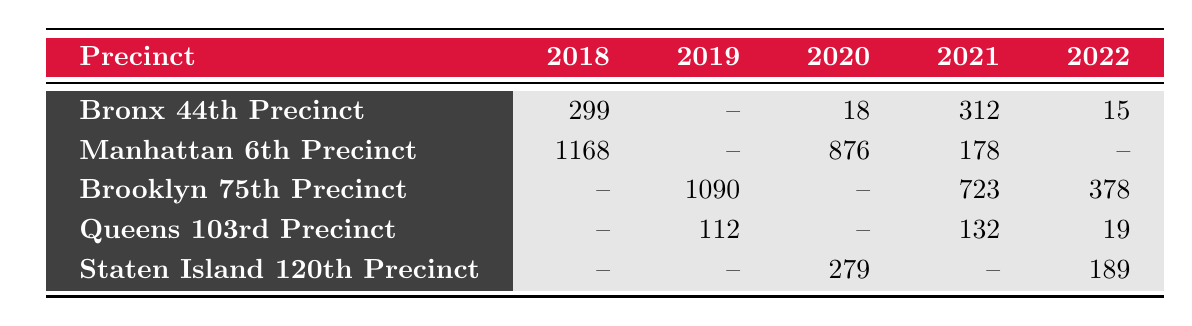What is the total number of offenses recorded in the Bronx 44th Precinct from 2018 to 2022? Looking at the Bronx 44th Precinct row, we see values for 2018 (299), 2020 (18), 2021 (312), and 2022 (15). We add these numbers: 299 + 18 + 312 + 15 = 644. There are no data points for 2019.
Answer: 644 Which year had the highest count of Grand Larceny in Manhattan 6th Precinct? The only year with data for Grand Larceny in the Manhattan 6th Precinct is 2018 (1023) and 2020 (876). Comparing these values, 1023 is greater than 876, thus 2018 had the highest count.
Answer: 2018 Did the number of Domestic Violence offenses in Staten Island 120th Precinct increase from 2020 to 2022? The data for Domestic Violence in Staten Island 120th Precinct shows 201 in 2020 and 189 in 2022. Here, 189 is less than 201, indicating a decrease.
Answer: No What was the average number of Auto Theft offenses in Queens 103rd Precinct over the years recorded? The data shows Auto Theft offenses for 2019 (89) and 2021 (132). We sum these: 89 + 132 = 221. There are 2 years of data, so the average is 221 / 2 = 110.5.
Answer: 110.5 Is it true that the total number of Drug Offenses in the Brooklyn 75th Precinct over the recorded years exceeded 1000? From the data, Drug Offenses for Brooklyn 75th Precinct are 412 in 2019 and 378 in 2022. Summing these, 412 + 378 = 790, which does not exceed 1000.
Answer: No What is the difference in the count of Homicides recorded in Bronx 44th Precinct between 2018 and 2020? The count of Homicides in Bronx 44th Precinct is 12 in 2018 and 18 in 2020. The difference is calculated as 18 - 12 = 6.
Answer: 6 What was the total recorded offense count for Manhattan 6th Precinct across the years 2018 to 2020? The recorded offense counts for Manhattan 6th Precinct are 1168 in 2018 and 876 in 2020 (there is no data for 2019). Adding these gives 1168 + 876 = 2044.
Answer: 2044 Which precinct recorded the least number of offenses among all listed for the years shown? By examining the total counts of each precinct, Bronx 44th Precinct had 644, Manhattan 6th Precinct had 2044, Brooklyn 75th Precinct had 1090, Queens 103rd Precinct had 250, and Staten Island 120th Precinct had 468. The least number is in Queens 103rd Precinct (250).
Answer: Queens 103rd Precinct 